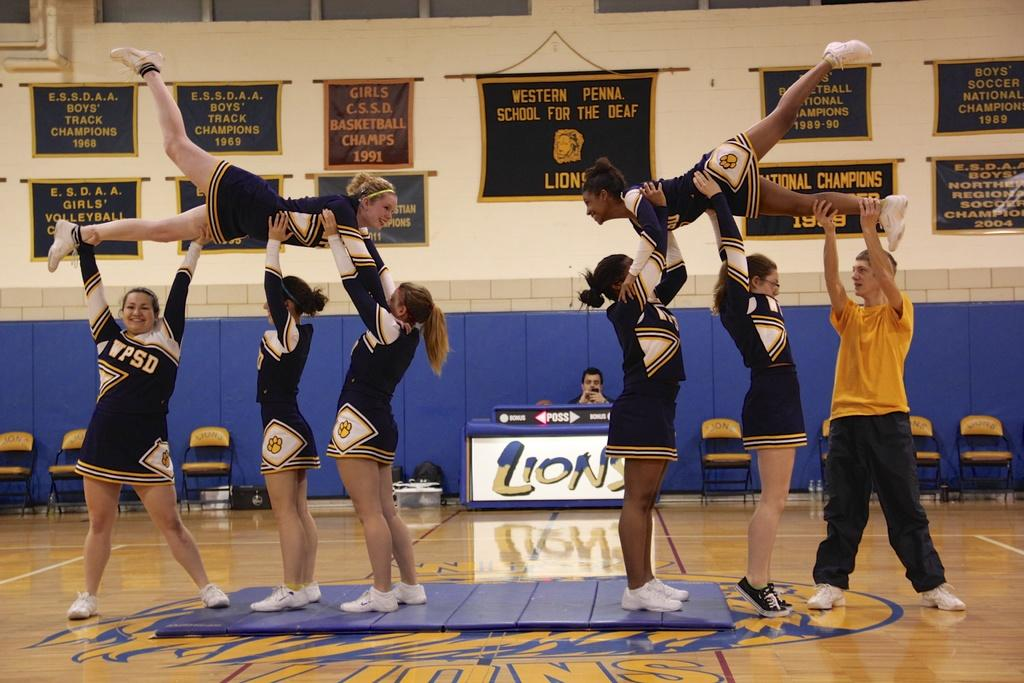<image>
Relay a brief, clear account of the picture shown. some cheerleaders in front of a Lions ad 